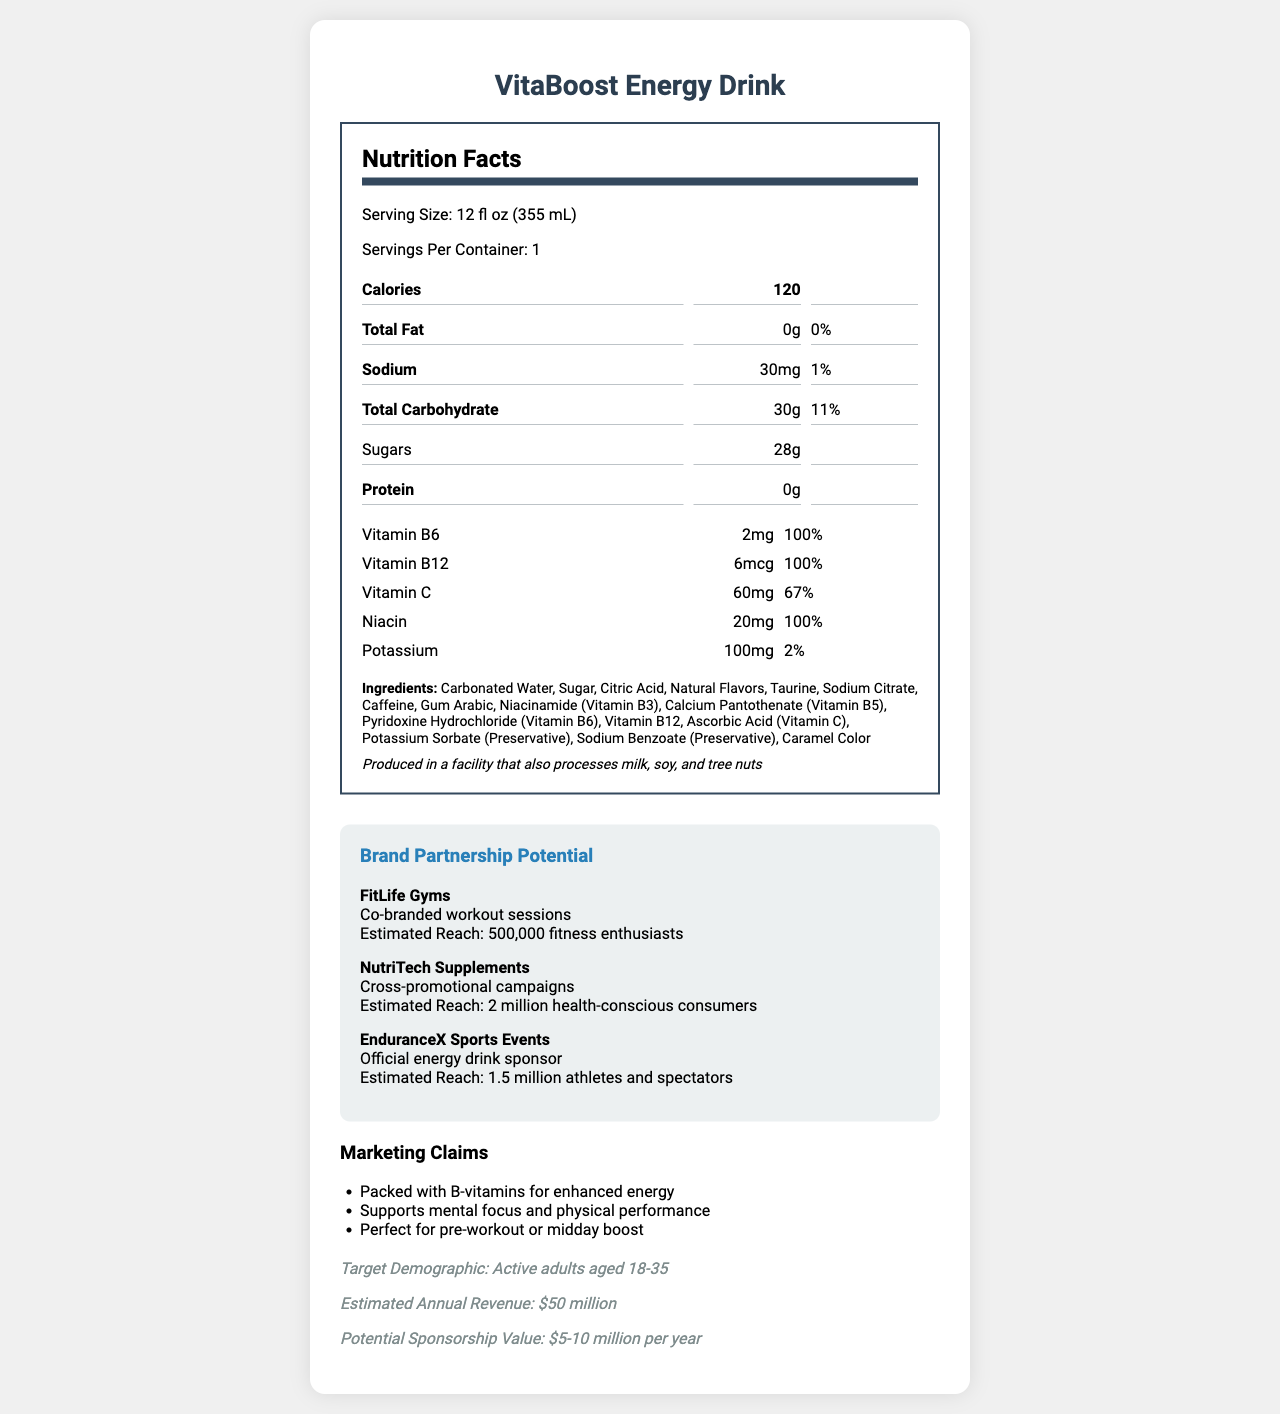what is the serving size of VitaBoost Energy Drink? The document lists the serving size as 12 fl oz (355 mL).
Answer: 12 fl oz (355 mL) how many calories are in one serving of VitaBoost Energy Drink? The document specifies that one serving contains 120 calories.
Answer: 120 what are the three vitamins provided in the VitaBoost Energy Drink, and what percent of daily value do they cover? The vitamins listed in the document include Vitamin B6 with 100% daily value, Vitamin B12 with 100% daily value, and Vitamin C with 67% daily value.
Answer: Vitamin B6 (100%), Vitamin B12 (100%), Vitamin C (67%) does the VitaBoost Energy Drink contain any protein? The document mentions that the drink has 0g of protein.
Answer: No what is the sodium content per serving? The document indicates that the sodium content per serving is 30mg, which is 1% of the daily value.
Answer: 30mg what are the primary ingredients in VitaBoost Energy Drink? A. Water, Sugar, Citric Acid, Natural Flavors B. Water, Aspartame, Citric Acid, Natural Flavors C. Water, Sugar, Stevia, Natural Flavors D. Water, Honey, Citric Acid, Natural Flavors The document lists ingredients including Carbonated Water, Sugar, Citric Acid, Natural Flavors, among others, making option A the correct one.
Answer: A. Water, Sugar, Citric Acid, Natural Flavors which partnership type is associated with FitLife Gyms? A. Cross-promotional campaigns B. Co-branded workout sessions C. Official energy drink sponsor D. Fitness product endorsements The document states that FitLife Gyms is associated with Co-branded workout sessions.
Answer: B. Co-branded workout sessions is VitaBoost Energy Drink suitable for people with soy allergies? The document states that the product is produced in a facility that also processes soy, so it's not clear if it's completely suitable for people with soy allergies.
Answer: Not enough information does the VitaBoost Energy Drink contain added caffeine? The document lists caffeine as one of the ingredients.
Answer: Yes what is the approximate annual revenue of VitaBoost Energy Drink? The document provides an estimated annual revenue of $50 million for VitaBoost Energy Drink.
Answer: $50 million summarize the main idea of the document. The document covers the nutritional facts, key vitamins and ingredients, potential health benefits, partnership opportunities with brands, and financial details of VitaBoost Energy Drink.
Answer: The document provides detailed nutritional information for VitaBoost Energy Drink, highlighting its vitamin content, ingredients, allergen information, marketing claims, target demographic, and brand partnership potentials with estimated reach and estimated annual revenue. who are the potential brand partners listed in the document? The document lists these three potential brand partners and their respective partnership types.
Answer: FitLife Gyms, NutriTech Supplements, EnduranceX Sports Events what health benefits does VitaBoost Energy Drink claim to provide? The document mentions these claims in its marketing section.
Answer: Enhanced energy, mental focus, physical performance, pre-workout or midday boost what is the target demographic for VitaBoost Energy Drink? The document specifies that the target demographic is active adults aged 18-35.
Answer: Active adults aged 18-35 how much potassium is in VitaBoost Energy Drink? The document shows that VitaBoost Energy Drink contains 100mg of potassium per serving.
Answer: 100mg which vitamin is not listed in the document? A. Vitamin A B. Vitamin B6 C. Vitamin B12 D. Vitamin C The document lists Vitamin B6, Vitamin B12, and Vitamin C, but not Vitamin A.
Answer: A. Vitamin A can the document provide the exact amount of sugar in the beverage? The document states that there are 28g of sugars per serving.
Answer: Yes 